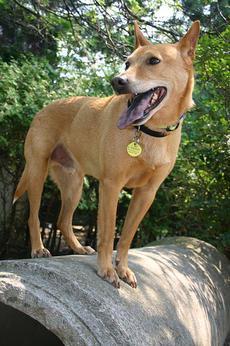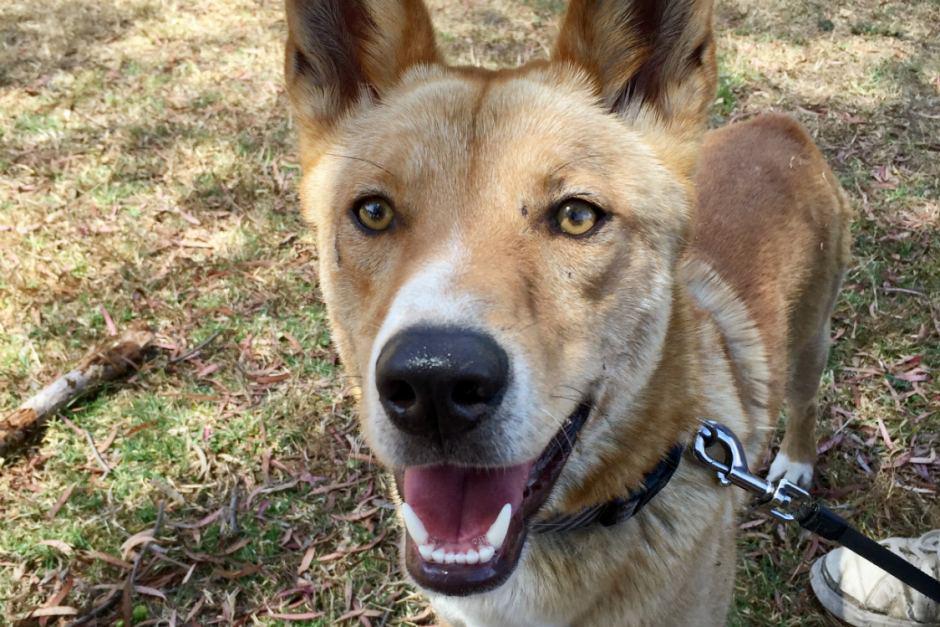The first image is the image on the left, the second image is the image on the right. For the images displayed, is the sentence "Every photo shows exactly one dog and all dogs are photographed outside, but the dog on the right has a visible leash attached to its collar." factually correct? Answer yes or no. Yes. The first image is the image on the left, the second image is the image on the right. Given the left and right images, does the statement "Two dingo pups are overlapping in the left image, with the dingo pup in front facing the camera." hold true? Answer yes or no. No. 